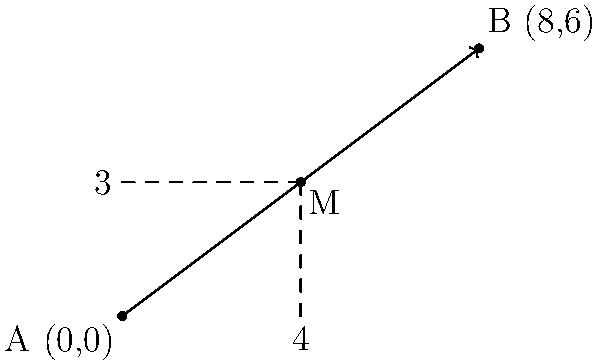A motorcycle enthusiast is planning a journey from point A (0,0) to point B (8,6) on a map. To arrange a meeting point with a detective, they need to determine the coordinates of the midpoint M of their journey. What are the coordinates of the midpoint M? To find the midpoint of a line segment, we can use the midpoint formula:

$$ M_x = \frac{x_1 + x_2}{2}, \quad M_y = \frac{y_1 + y_2}{2} $$

Where $(x_1, y_1)$ are the coordinates of point A, and $(x_2, y_2)$ are the coordinates of point B.

Given:
- Point A: (0,0)
- Point B: (8,6)

Step 1: Calculate the x-coordinate of the midpoint:
$$ M_x = \frac{x_1 + x_2}{2} = \frac{0 + 8}{2} = \frac{8}{2} = 4 $$

Step 2: Calculate the y-coordinate of the midpoint:
$$ M_y = \frac{y_1 + y_2}{2} = \frac{0 + 6}{2} = \frac{6}{2} = 3 $$

Therefore, the coordinates of the midpoint M are (4,3).
Answer: (4,3) 